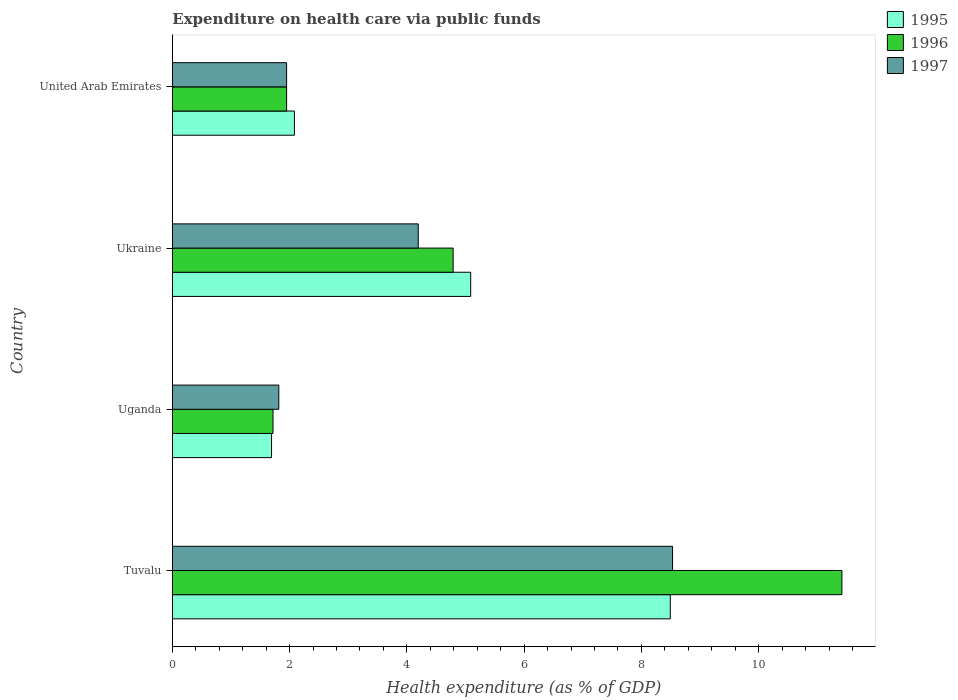How many groups of bars are there?
Your response must be concise. 4. Are the number of bars per tick equal to the number of legend labels?
Keep it short and to the point. Yes. How many bars are there on the 4th tick from the top?
Keep it short and to the point. 3. How many bars are there on the 2nd tick from the bottom?
Your answer should be very brief. 3. What is the label of the 3rd group of bars from the top?
Provide a succinct answer. Uganda. In how many cases, is the number of bars for a given country not equal to the number of legend labels?
Give a very brief answer. 0. What is the expenditure made on health care in 1995 in Tuvalu?
Your answer should be very brief. 8.49. Across all countries, what is the maximum expenditure made on health care in 1997?
Provide a short and direct response. 8.53. Across all countries, what is the minimum expenditure made on health care in 1995?
Your response must be concise. 1.69. In which country was the expenditure made on health care in 1997 maximum?
Your answer should be very brief. Tuvalu. In which country was the expenditure made on health care in 1997 minimum?
Offer a very short reply. Uganda. What is the total expenditure made on health care in 1995 in the graph?
Your answer should be compact. 17.35. What is the difference between the expenditure made on health care in 1996 in Tuvalu and that in United Arab Emirates?
Provide a short and direct response. 9.47. What is the difference between the expenditure made on health care in 1995 in Uganda and the expenditure made on health care in 1996 in United Arab Emirates?
Your response must be concise. -0.26. What is the average expenditure made on health care in 1997 per country?
Make the answer very short. 4.12. What is the difference between the expenditure made on health care in 1997 and expenditure made on health care in 1995 in United Arab Emirates?
Ensure brevity in your answer.  -0.13. In how many countries, is the expenditure made on health care in 1995 greater than 1.2000000000000002 %?
Offer a very short reply. 4. What is the ratio of the expenditure made on health care in 1996 in Uganda to that in United Arab Emirates?
Provide a succinct answer. 0.88. Is the difference between the expenditure made on health care in 1997 in Uganda and Ukraine greater than the difference between the expenditure made on health care in 1995 in Uganda and Ukraine?
Offer a terse response. Yes. What is the difference between the highest and the second highest expenditure made on health care in 1997?
Provide a short and direct response. 4.34. What is the difference between the highest and the lowest expenditure made on health care in 1997?
Provide a short and direct response. 6.72. In how many countries, is the expenditure made on health care in 1995 greater than the average expenditure made on health care in 1995 taken over all countries?
Ensure brevity in your answer.  2. What does the 3rd bar from the top in Ukraine represents?
Keep it short and to the point. 1995. What does the 1st bar from the bottom in Uganda represents?
Provide a succinct answer. 1995. Are all the bars in the graph horizontal?
Your answer should be very brief. Yes. How many countries are there in the graph?
Your response must be concise. 4. What is the difference between two consecutive major ticks on the X-axis?
Provide a short and direct response. 2. Are the values on the major ticks of X-axis written in scientific E-notation?
Offer a very short reply. No. Does the graph contain any zero values?
Offer a terse response. No. Does the graph contain grids?
Keep it short and to the point. No. Where does the legend appear in the graph?
Make the answer very short. Top right. How are the legend labels stacked?
Offer a very short reply. Vertical. What is the title of the graph?
Your answer should be very brief. Expenditure on health care via public funds. What is the label or title of the X-axis?
Give a very brief answer. Health expenditure (as % of GDP). What is the Health expenditure (as % of GDP) in 1995 in Tuvalu?
Make the answer very short. 8.49. What is the Health expenditure (as % of GDP) in 1996 in Tuvalu?
Keep it short and to the point. 11.42. What is the Health expenditure (as % of GDP) in 1997 in Tuvalu?
Offer a very short reply. 8.53. What is the Health expenditure (as % of GDP) in 1995 in Uganda?
Your answer should be compact. 1.69. What is the Health expenditure (as % of GDP) in 1996 in Uganda?
Provide a succinct answer. 1.72. What is the Health expenditure (as % of GDP) of 1997 in Uganda?
Your answer should be very brief. 1.82. What is the Health expenditure (as % of GDP) in 1995 in Ukraine?
Provide a succinct answer. 5.09. What is the Health expenditure (as % of GDP) of 1996 in Ukraine?
Ensure brevity in your answer.  4.79. What is the Health expenditure (as % of GDP) in 1997 in Ukraine?
Your answer should be very brief. 4.19. What is the Health expenditure (as % of GDP) in 1995 in United Arab Emirates?
Provide a short and direct response. 2.08. What is the Health expenditure (as % of GDP) in 1996 in United Arab Emirates?
Your answer should be very brief. 1.95. What is the Health expenditure (as % of GDP) of 1997 in United Arab Emirates?
Keep it short and to the point. 1.95. Across all countries, what is the maximum Health expenditure (as % of GDP) of 1995?
Your answer should be compact. 8.49. Across all countries, what is the maximum Health expenditure (as % of GDP) of 1996?
Give a very brief answer. 11.42. Across all countries, what is the maximum Health expenditure (as % of GDP) of 1997?
Offer a very short reply. 8.53. Across all countries, what is the minimum Health expenditure (as % of GDP) in 1995?
Provide a succinct answer. 1.69. Across all countries, what is the minimum Health expenditure (as % of GDP) of 1996?
Offer a terse response. 1.72. Across all countries, what is the minimum Health expenditure (as % of GDP) in 1997?
Provide a short and direct response. 1.82. What is the total Health expenditure (as % of GDP) of 1995 in the graph?
Provide a succinct answer. 17.35. What is the total Health expenditure (as % of GDP) in 1996 in the graph?
Provide a short and direct response. 19.87. What is the total Health expenditure (as % of GDP) of 1997 in the graph?
Provide a succinct answer. 16.49. What is the difference between the Health expenditure (as % of GDP) of 1995 in Tuvalu and that in Uganda?
Make the answer very short. 6.8. What is the difference between the Health expenditure (as % of GDP) of 1996 in Tuvalu and that in Uganda?
Your response must be concise. 9.7. What is the difference between the Health expenditure (as % of GDP) in 1997 in Tuvalu and that in Uganda?
Provide a succinct answer. 6.72. What is the difference between the Health expenditure (as % of GDP) in 1995 in Tuvalu and that in Ukraine?
Keep it short and to the point. 3.4. What is the difference between the Health expenditure (as % of GDP) in 1996 in Tuvalu and that in Ukraine?
Keep it short and to the point. 6.63. What is the difference between the Health expenditure (as % of GDP) in 1997 in Tuvalu and that in Ukraine?
Offer a very short reply. 4.34. What is the difference between the Health expenditure (as % of GDP) of 1995 in Tuvalu and that in United Arab Emirates?
Keep it short and to the point. 6.41. What is the difference between the Health expenditure (as % of GDP) in 1996 in Tuvalu and that in United Arab Emirates?
Your answer should be compact. 9.47. What is the difference between the Health expenditure (as % of GDP) of 1997 in Tuvalu and that in United Arab Emirates?
Ensure brevity in your answer.  6.58. What is the difference between the Health expenditure (as % of GDP) in 1995 in Uganda and that in Ukraine?
Give a very brief answer. -3.4. What is the difference between the Health expenditure (as % of GDP) in 1996 in Uganda and that in Ukraine?
Offer a terse response. -3.07. What is the difference between the Health expenditure (as % of GDP) in 1997 in Uganda and that in Ukraine?
Your response must be concise. -2.38. What is the difference between the Health expenditure (as % of GDP) in 1995 in Uganda and that in United Arab Emirates?
Provide a succinct answer. -0.39. What is the difference between the Health expenditure (as % of GDP) in 1996 in Uganda and that in United Arab Emirates?
Your answer should be compact. -0.23. What is the difference between the Health expenditure (as % of GDP) of 1997 in Uganda and that in United Arab Emirates?
Your answer should be compact. -0.13. What is the difference between the Health expenditure (as % of GDP) in 1995 in Ukraine and that in United Arab Emirates?
Make the answer very short. 3.01. What is the difference between the Health expenditure (as % of GDP) in 1996 in Ukraine and that in United Arab Emirates?
Make the answer very short. 2.84. What is the difference between the Health expenditure (as % of GDP) of 1997 in Ukraine and that in United Arab Emirates?
Provide a short and direct response. 2.25. What is the difference between the Health expenditure (as % of GDP) of 1995 in Tuvalu and the Health expenditure (as % of GDP) of 1996 in Uganda?
Offer a very short reply. 6.78. What is the difference between the Health expenditure (as % of GDP) in 1995 in Tuvalu and the Health expenditure (as % of GDP) in 1997 in Uganda?
Your answer should be very brief. 6.68. What is the difference between the Health expenditure (as % of GDP) in 1996 in Tuvalu and the Health expenditure (as % of GDP) in 1997 in Uganda?
Offer a terse response. 9.6. What is the difference between the Health expenditure (as % of GDP) in 1995 in Tuvalu and the Health expenditure (as % of GDP) in 1996 in Ukraine?
Give a very brief answer. 3.7. What is the difference between the Health expenditure (as % of GDP) in 1995 in Tuvalu and the Health expenditure (as % of GDP) in 1997 in Ukraine?
Provide a short and direct response. 4.3. What is the difference between the Health expenditure (as % of GDP) in 1996 in Tuvalu and the Health expenditure (as % of GDP) in 1997 in Ukraine?
Your answer should be very brief. 7.23. What is the difference between the Health expenditure (as % of GDP) of 1995 in Tuvalu and the Health expenditure (as % of GDP) of 1996 in United Arab Emirates?
Keep it short and to the point. 6.54. What is the difference between the Health expenditure (as % of GDP) in 1995 in Tuvalu and the Health expenditure (as % of GDP) in 1997 in United Arab Emirates?
Provide a short and direct response. 6.54. What is the difference between the Health expenditure (as % of GDP) of 1996 in Tuvalu and the Health expenditure (as % of GDP) of 1997 in United Arab Emirates?
Your answer should be very brief. 9.47. What is the difference between the Health expenditure (as % of GDP) in 1995 in Uganda and the Health expenditure (as % of GDP) in 1996 in Ukraine?
Your answer should be compact. -3.1. What is the difference between the Health expenditure (as % of GDP) of 1995 in Uganda and the Health expenditure (as % of GDP) of 1997 in Ukraine?
Your answer should be compact. -2.5. What is the difference between the Health expenditure (as % of GDP) of 1996 in Uganda and the Health expenditure (as % of GDP) of 1997 in Ukraine?
Provide a short and direct response. -2.48. What is the difference between the Health expenditure (as % of GDP) of 1995 in Uganda and the Health expenditure (as % of GDP) of 1996 in United Arab Emirates?
Ensure brevity in your answer.  -0.26. What is the difference between the Health expenditure (as % of GDP) of 1995 in Uganda and the Health expenditure (as % of GDP) of 1997 in United Arab Emirates?
Offer a terse response. -0.26. What is the difference between the Health expenditure (as % of GDP) in 1996 in Uganda and the Health expenditure (as % of GDP) in 1997 in United Arab Emirates?
Your answer should be very brief. -0.23. What is the difference between the Health expenditure (as % of GDP) in 1995 in Ukraine and the Health expenditure (as % of GDP) in 1996 in United Arab Emirates?
Provide a succinct answer. 3.14. What is the difference between the Health expenditure (as % of GDP) in 1995 in Ukraine and the Health expenditure (as % of GDP) in 1997 in United Arab Emirates?
Your answer should be very brief. 3.14. What is the difference between the Health expenditure (as % of GDP) in 1996 in Ukraine and the Health expenditure (as % of GDP) in 1997 in United Arab Emirates?
Make the answer very short. 2.84. What is the average Health expenditure (as % of GDP) in 1995 per country?
Give a very brief answer. 4.34. What is the average Health expenditure (as % of GDP) of 1996 per country?
Offer a terse response. 4.97. What is the average Health expenditure (as % of GDP) in 1997 per country?
Make the answer very short. 4.12. What is the difference between the Health expenditure (as % of GDP) of 1995 and Health expenditure (as % of GDP) of 1996 in Tuvalu?
Provide a succinct answer. -2.93. What is the difference between the Health expenditure (as % of GDP) of 1995 and Health expenditure (as % of GDP) of 1997 in Tuvalu?
Your answer should be compact. -0.04. What is the difference between the Health expenditure (as % of GDP) of 1996 and Health expenditure (as % of GDP) of 1997 in Tuvalu?
Provide a succinct answer. 2.89. What is the difference between the Health expenditure (as % of GDP) of 1995 and Health expenditure (as % of GDP) of 1996 in Uganda?
Provide a succinct answer. -0.02. What is the difference between the Health expenditure (as % of GDP) of 1995 and Health expenditure (as % of GDP) of 1997 in Uganda?
Your response must be concise. -0.12. What is the difference between the Health expenditure (as % of GDP) in 1996 and Health expenditure (as % of GDP) in 1997 in Uganda?
Make the answer very short. -0.1. What is the difference between the Health expenditure (as % of GDP) of 1995 and Health expenditure (as % of GDP) of 1996 in Ukraine?
Keep it short and to the point. 0.3. What is the difference between the Health expenditure (as % of GDP) in 1995 and Health expenditure (as % of GDP) in 1997 in Ukraine?
Provide a succinct answer. 0.89. What is the difference between the Health expenditure (as % of GDP) of 1996 and Health expenditure (as % of GDP) of 1997 in Ukraine?
Ensure brevity in your answer.  0.6. What is the difference between the Health expenditure (as % of GDP) in 1995 and Health expenditure (as % of GDP) in 1996 in United Arab Emirates?
Keep it short and to the point. 0.13. What is the difference between the Health expenditure (as % of GDP) in 1995 and Health expenditure (as % of GDP) in 1997 in United Arab Emirates?
Make the answer very short. 0.13. What is the ratio of the Health expenditure (as % of GDP) of 1995 in Tuvalu to that in Uganda?
Make the answer very short. 5.02. What is the ratio of the Health expenditure (as % of GDP) of 1996 in Tuvalu to that in Uganda?
Give a very brief answer. 6.65. What is the ratio of the Health expenditure (as % of GDP) of 1997 in Tuvalu to that in Uganda?
Your response must be concise. 4.7. What is the ratio of the Health expenditure (as % of GDP) of 1995 in Tuvalu to that in Ukraine?
Offer a terse response. 1.67. What is the ratio of the Health expenditure (as % of GDP) of 1996 in Tuvalu to that in Ukraine?
Provide a succinct answer. 2.38. What is the ratio of the Health expenditure (as % of GDP) of 1997 in Tuvalu to that in Ukraine?
Offer a terse response. 2.03. What is the ratio of the Health expenditure (as % of GDP) of 1995 in Tuvalu to that in United Arab Emirates?
Offer a very short reply. 4.08. What is the ratio of the Health expenditure (as % of GDP) of 1996 in Tuvalu to that in United Arab Emirates?
Give a very brief answer. 5.86. What is the ratio of the Health expenditure (as % of GDP) in 1997 in Tuvalu to that in United Arab Emirates?
Your response must be concise. 4.38. What is the ratio of the Health expenditure (as % of GDP) of 1995 in Uganda to that in Ukraine?
Provide a short and direct response. 0.33. What is the ratio of the Health expenditure (as % of GDP) of 1996 in Uganda to that in Ukraine?
Your answer should be compact. 0.36. What is the ratio of the Health expenditure (as % of GDP) in 1997 in Uganda to that in Ukraine?
Your answer should be very brief. 0.43. What is the ratio of the Health expenditure (as % of GDP) in 1995 in Uganda to that in United Arab Emirates?
Offer a terse response. 0.81. What is the ratio of the Health expenditure (as % of GDP) in 1996 in Uganda to that in United Arab Emirates?
Your response must be concise. 0.88. What is the ratio of the Health expenditure (as % of GDP) of 1997 in Uganda to that in United Arab Emirates?
Provide a succinct answer. 0.93. What is the ratio of the Health expenditure (as % of GDP) in 1995 in Ukraine to that in United Arab Emirates?
Offer a terse response. 2.44. What is the ratio of the Health expenditure (as % of GDP) in 1996 in Ukraine to that in United Arab Emirates?
Ensure brevity in your answer.  2.46. What is the ratio of the Health expenditure (as % of GDP) of 1997 in Ukraine to that in United Arab Emirates?
Offer a very short reply. 2.15. What is the difference between the highest and the second highest Health expenditure (as % of GDP) of 1995?
Your answer should be very brief. 3.4. What is the difference between the highest and the second highest Health expenditure (as % of GDP) in 1996?
Ensure brevity in your answer.  6.63. What is the difference between the highest and the second highest Health expenditure (as % of GDP) of 1997?
Ensure brevity in your answer.  4.34. What is the difference between the highest and the lowest Health expenditure (as % of GDP) in 1995?
Provide a succinct answer. 6.8. What is the difference between the highest and the lowest Health expenditure (as % of GDP) of 1996?
Your answer should be compact. 9.7. What is the difference between the highest and the lowest Health expenditure (as % of GDP) in 1997?
Make the answer very short. 6.72. 